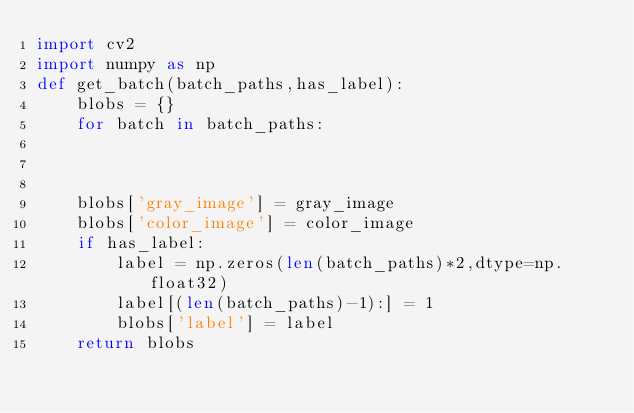Convert code to text. <code><loc_0><loc_0><loc_500><loc_500><_Python_>import cv2
import numpy as np
def get_batch(batch_paths,has_label):
    blobs = {}
    for batch in batch_paths:



    blobs['gray_image'] = gray_image
    blobs['color_image'] = color_image
    if has_label:
        label = np.zeros(len(batch_paths)*2,dtype=np.float32)
        label[(len(batch_paths)-1):] = 1
        blobs['label'] = label
    return blobs

</code> 